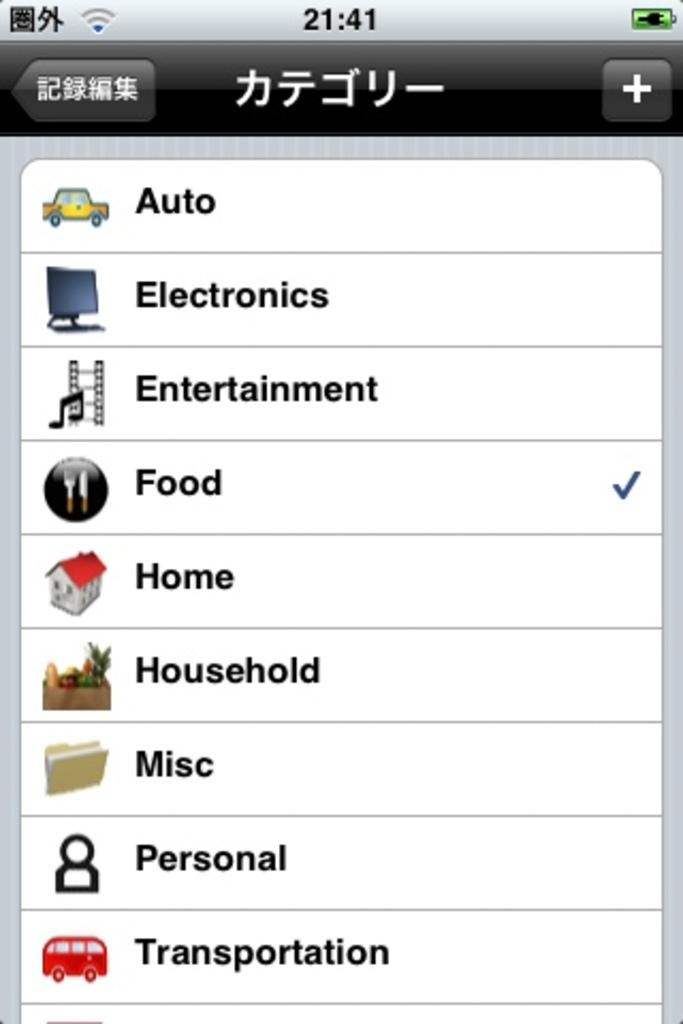<image>
Create a compact narrative representing the image presented. A phone with the time 21:41 displays different tabs like Food and Household. 